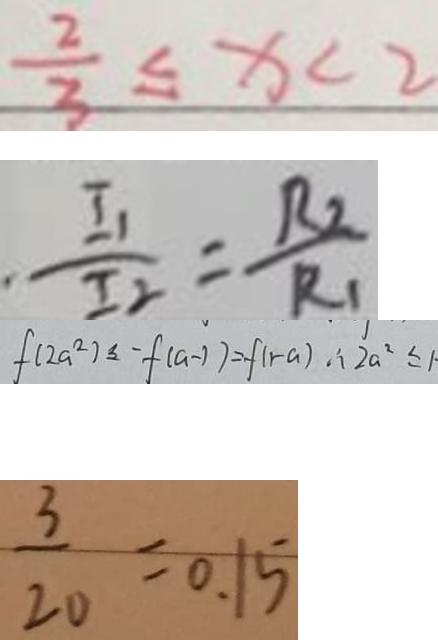Convert formula to latex. <formula><loc_0><loc_0><loc_500><loc_500>\frac { 2 } { 3 } \leq x < 2 
 \frac { I _ { 1 } } { I _ { 2 } } = \frac { R _ { 2 } } { R _ { 1 } } 
 f ( 2 a ^ { 2 } ) \leq - f ( a - 1 ) = f ( 1 - a ) \therefore 2 a ^ { 2 } \leq 1 \cdot 
 \frac { 3 } { 2 0 } = 0 . 1 5</formula> 